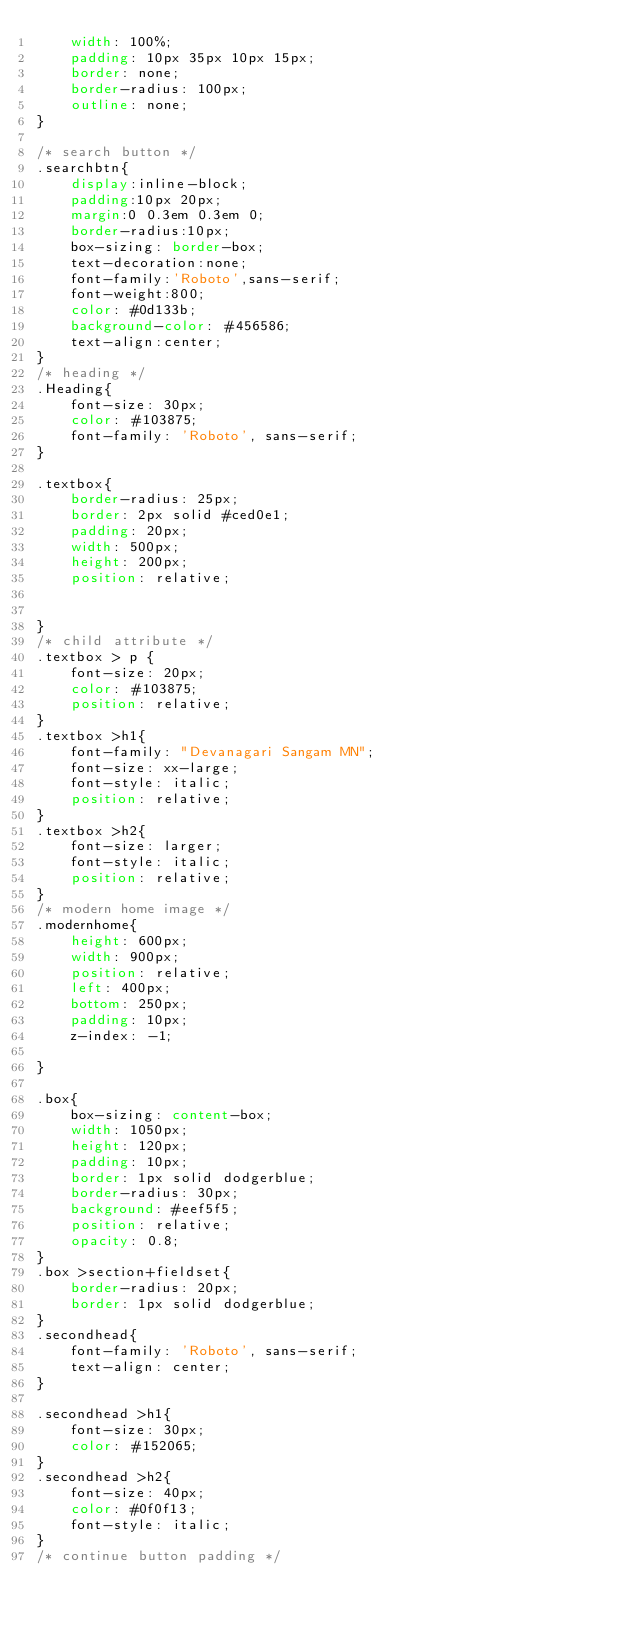<code> <loc_0><loc_0><loc_500><loc_500><_CSS_>    width: 100%;
    padding: 10px 35px 10px 15px;
    border: none;
    border-radius: 100px;
    outline: none;
}

/* search button */
.searchbtn{
    display:inline-block;
    padding:10px 20px;
    margin:0 0.3em 0.3em 0;
    border-radius:10px;
    box-sizing: border-box;
    text-decoration:none;
    font-family:'Roboto',sans-serif;
    font-weight:800;
    color: #0d133b;
    background-color: #456586;
    text-align:center;
}
/* heading */
.Heading{
    font-size: 30px;
    color: #103875;
    font-family: 'Roboto', sans-serif;
}

.textbox{
    border-radius: 25px;
    border: 2px solid #ced0e1;
    padding: 20px;
    width: 500px;
    height: 200px;
    position: relative;


}
/* child attribute */
.textbox > p {
    font-size: 20px;
    color: #103875;
    position: relative;
}
.textbox >h1{
    font-family: "Devanagari Sangam MN";
    font-size: xx-large;
    font-style: italic;
    position: relative;
}
.textbox >h2{
    font-size: larger;
    font-style: italic;
    position: relative;
}
/* modern home image */
.modernhome{
    height: 600px;
    width: 900px;
    position: relative;
    left: 400px;
    bottom: 250px;
    padding: 10px;
    z-index: -1;

}

.box{
    box-sizing: content-box;
    width: 1050px;
    height: 120px;
    padding: 10px;
    border: 1px solid dodgerblue;
    border-radius: 30px;
    background: #eef5f5;
    position: relative;
    opacity: 0.8;
}
.box >section+fieldset{
    border-radius: 20px;
    border: 1px solid dodgerblue;
}
.secondhead{
    font-family: 'Roboto', sans-serif;
    text-align: center;
}

.secondhead >h1{
    font-size: 30px;
    color: #152065;
}
.secondhead >h2{
    font-size: 40px;
    color: #0f0f13;
    font-style: italic;
}
/* continue button padding */</code> 